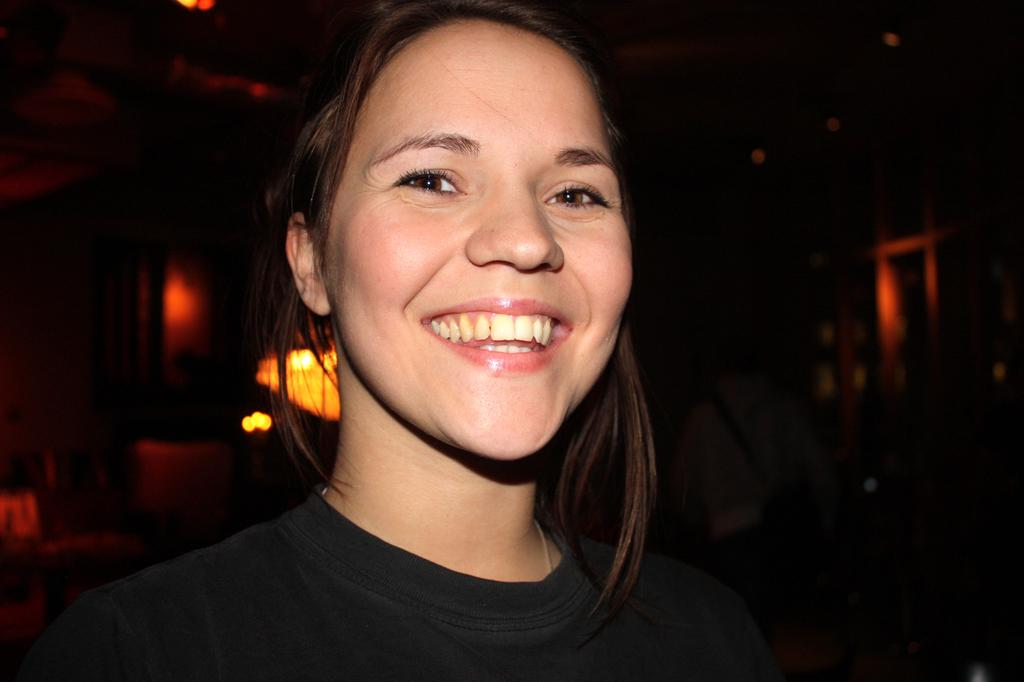Who is present in the image? There is a woman and another person in the image. What is the woman doing in the image? The woman is watching and smiling. What can be observed about the background of the image? The background of the image is dark. Are there any light sources visible in the image? Yes, there are lights visible in the image. What type of coil is being played by the woman in the image? There is no coil or musical instrument present in the image; the woman is simply watching and smiling. 